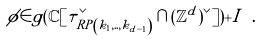<formula> <loc_0><loc_0><loc_500><loc_500>\phi \in g ( \mathbb { C } [ \tau _ { R P \left ( k _ { 1 } , . . , k _ { d - 1 } \right ) } ^ { \vee } \cap ( \mathbb { Z } ^ { d } ) ^ { \vee } ] ) + I \ . \</formula> 